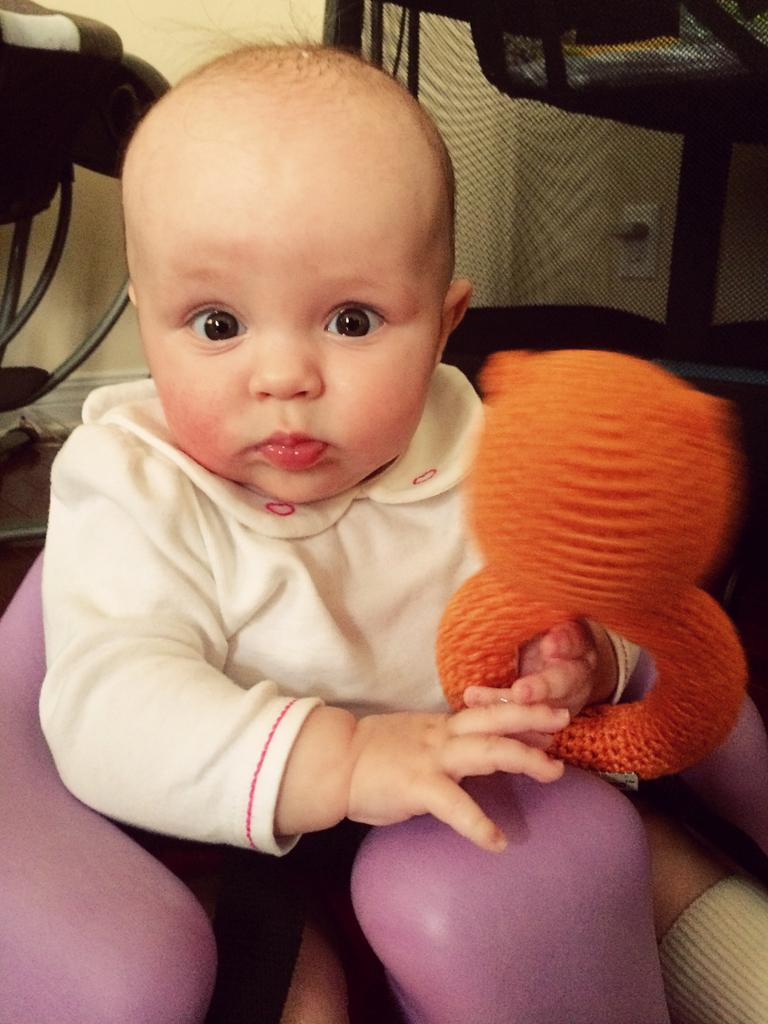What is the main subject of the image? There is a baby sitting in the image. What is the baby holding in their hand? The baby is holding something in their hand. Can you describe the background of the image? There are objects in the background of the image. What type of station is visible in the background of the image? There is no station present in the image; it features a baby sitting and holding something in their hand. What is the taste of the attraction in the image? There is no attraction present in the image, and therefore no taste can be determined. 